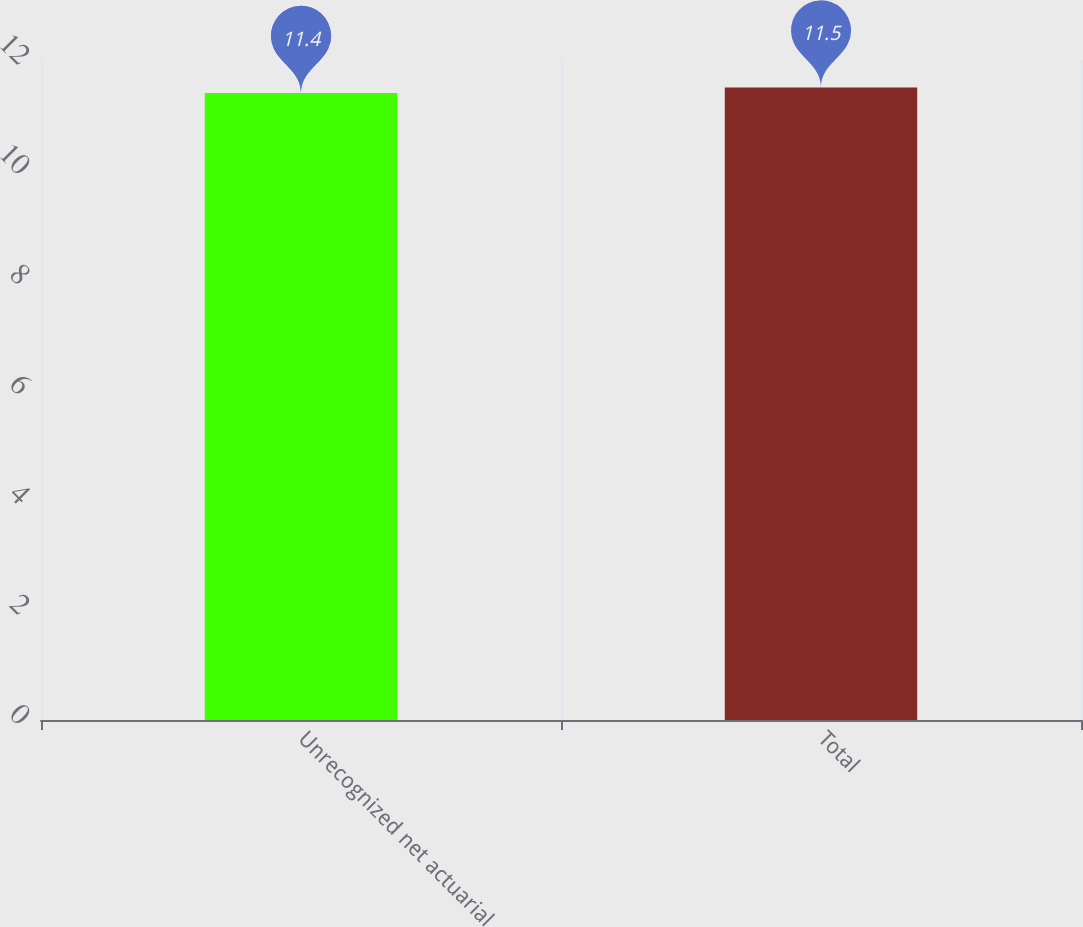<chart> <loc_0><loc_0><loc_500><loc_500><bar_chart><fcel>Unrecognized net actuarial<fcel>Total<nl><fcel>11.4<fcel>11.5<nl></chart> 